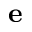Convert formula to latex. <formula><loc_0><loc_0><loc_500><loc_500>e</formula> 